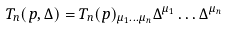Convert formula to latex. <formula><loc_0><loc_0><loc_500><loc_500>T _ { n } ( p , \Delta ) = T _ { n } ( p ) _ { \mu _ { 1 } \dots \mu _ { n } } \Delta ^ { \mu _ { 1 } } \dots \Delta ^ { \mu _ { n } }</formula> 